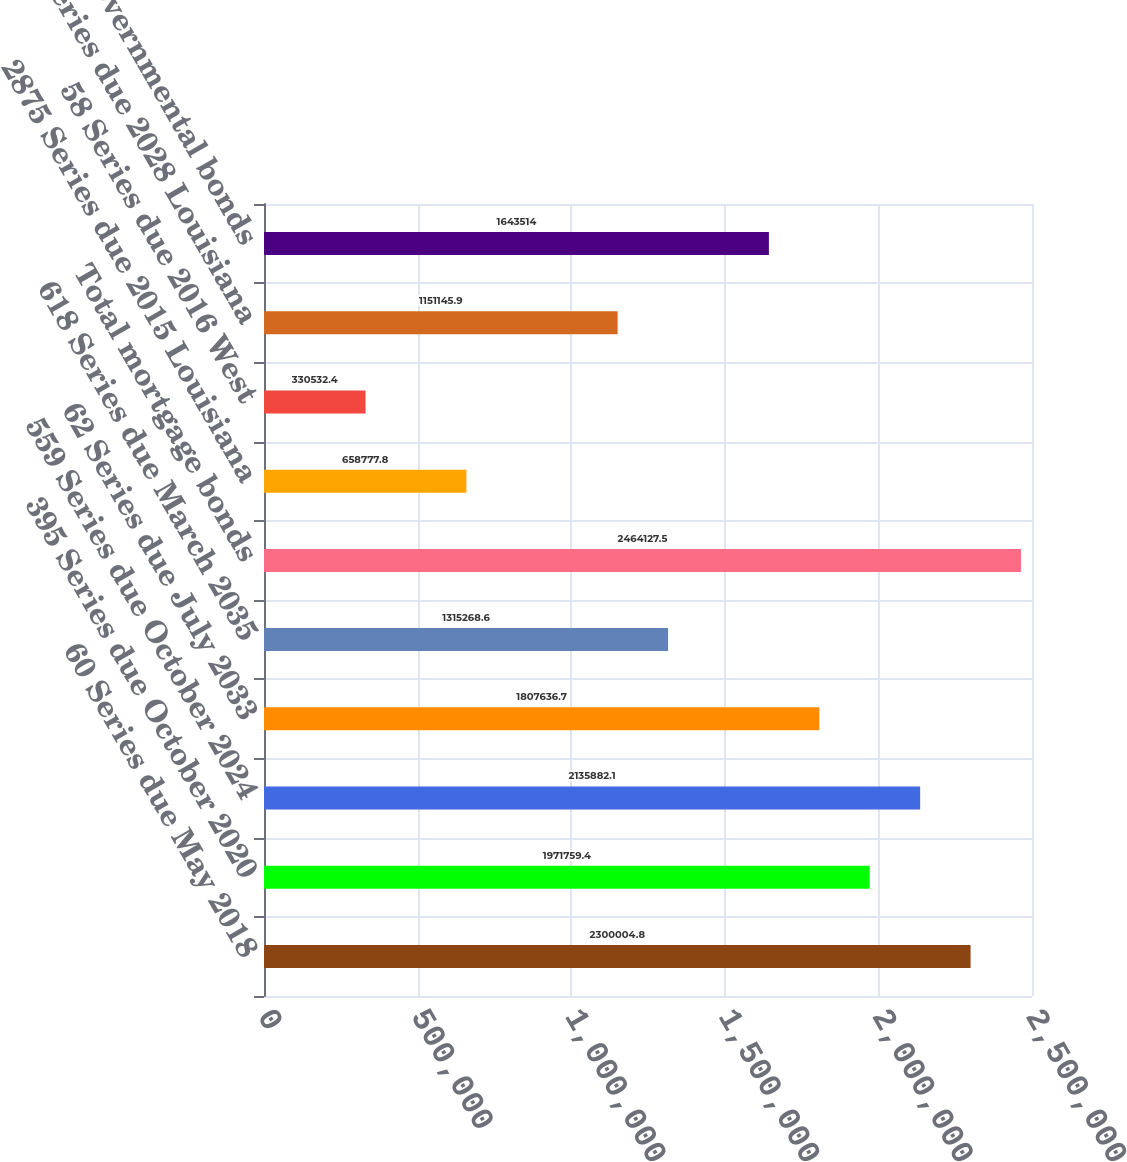<chart> <loc_0><loc_0><loc_500><loc_500><bar_chart><fcel>60 Series due May 2018<fcel>395 Series due October 2020<fcel>559 Series due October 2024<fcel>62 Series due July 2033<fcel>618 Series due March 2035<fcel>Total mortgage bonds<fcel>2875 Series due 2015 Louisiana<fcel>58 Series due 2016 West<fcel>50 Series due 2028 Louisiana<fcel>Total governmental bonds<nl><fcel>2.3e+06<fcel>1.97176e+06<fcel>2.13588e+06<fcel>1.80764e+06<fcel>1.31527e+06<fcel>2.46413e+06<fcel>658778<fcel>330532<fcel>1.15115e+06<fcel>1.64351e+06<nl></chart> 